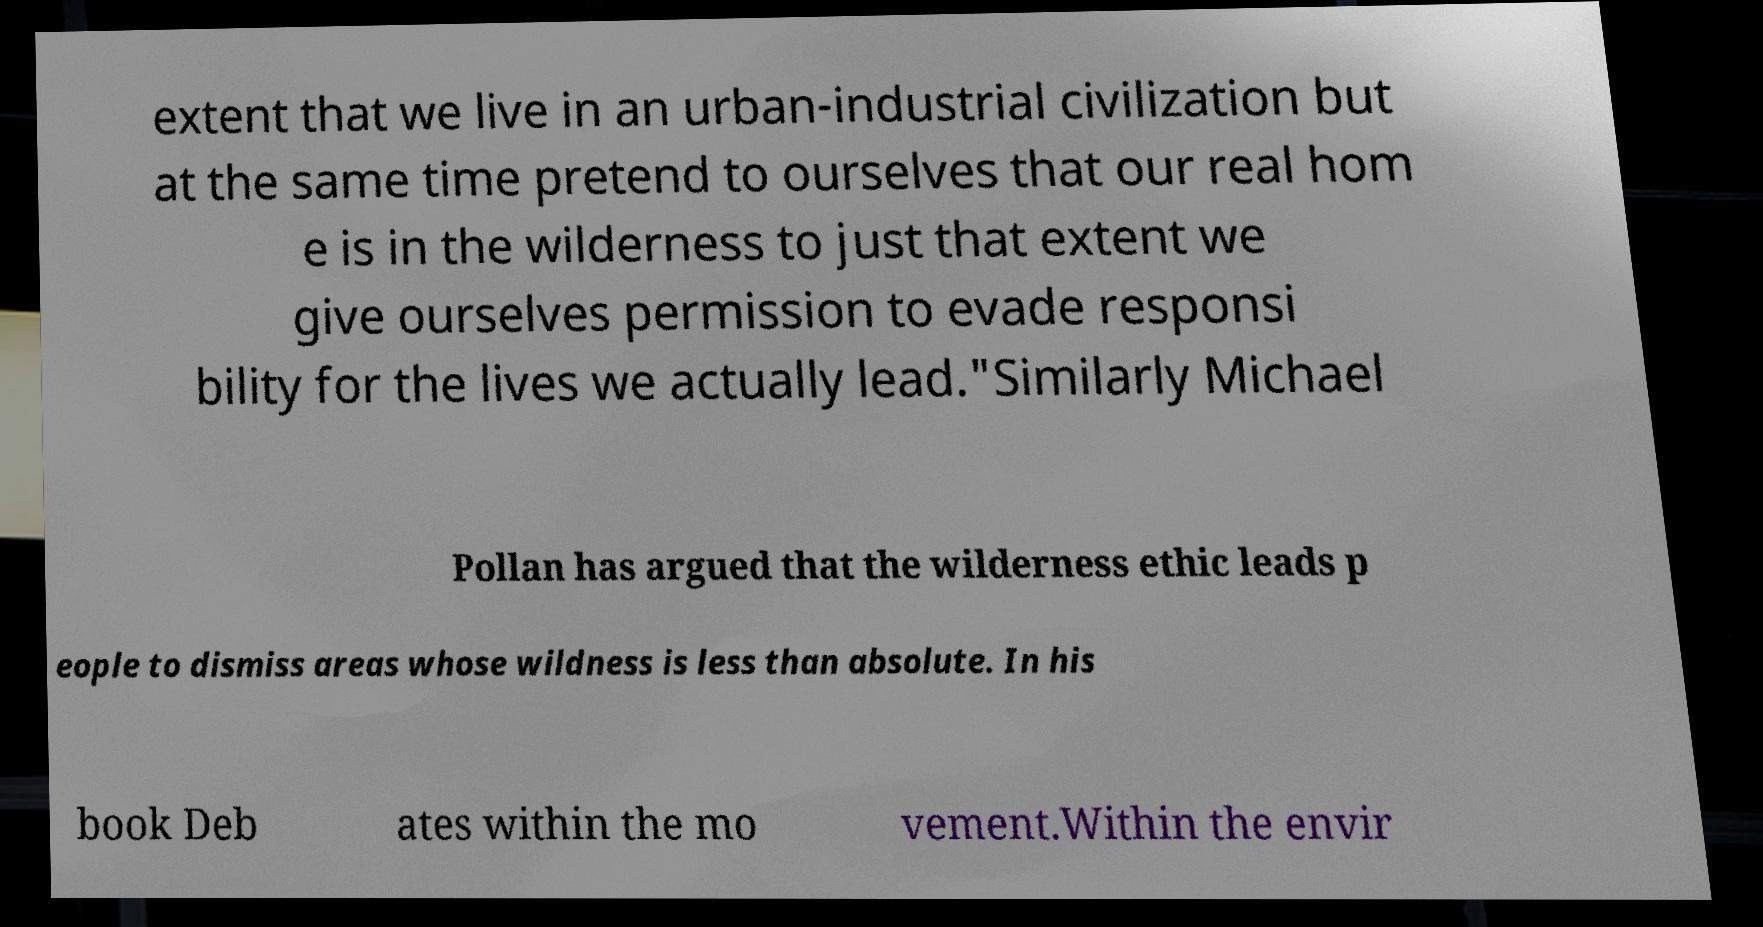I need the written content from this picture converted into text. Can you do that? extent that we live in an urban-industrial civilization but at the same time pretend to ourselves that our real hom e is in the wilderness to just that extent we give ourselves permission to evade responsi bility for the lives we actually lead."Similarly Michael Pollan has argued that the wilderness ethic leads p eople to dismiss areas whose wildness is less than absolute. In his book Deb ates within the mo vement.Within the envir 